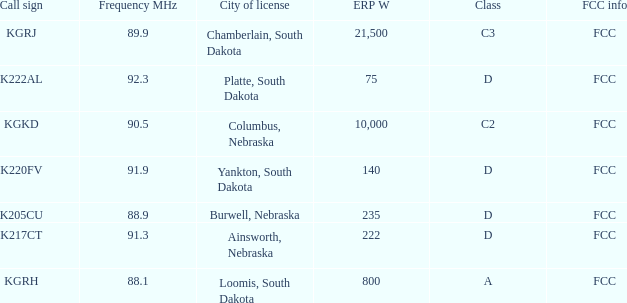What is the call sign with a 222 erp w? K217CT. 